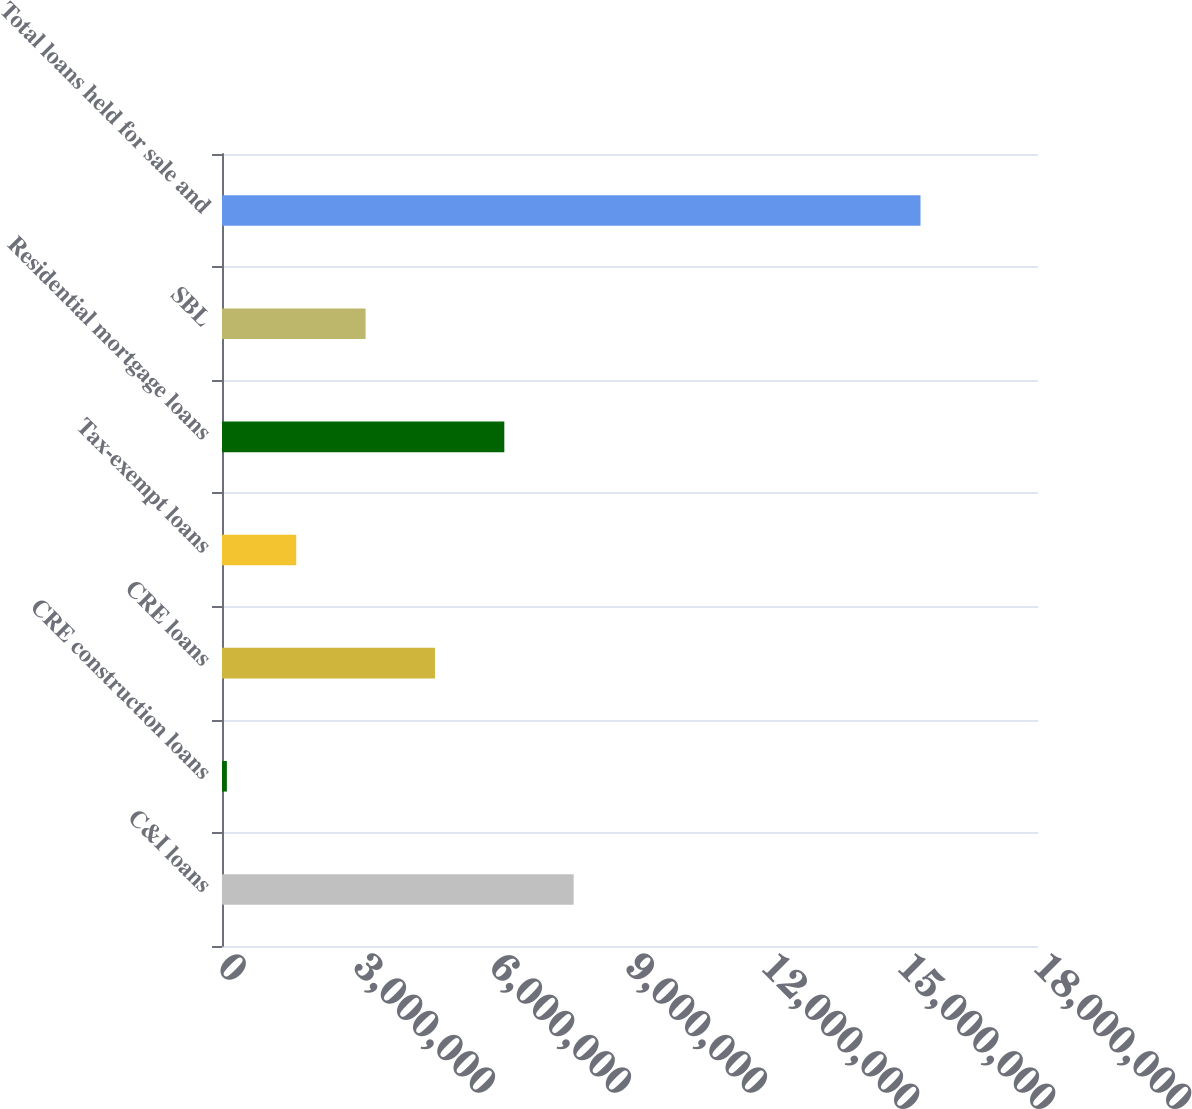Convert chart to OTSL. <chart><loc_0><loc_0><loc_500><loc_500><bar_chart><fcel>C&I loans<fcel>CRE construction loans<fcel>CRE loans<fcel>Tax-exempt loans<fcel>Residential mortgage loans<fcel>SBL<fcel>Total loans held for sale and<nl><fcel>7.75778e+06<fcel>107437<fcel>4.69764e+06<fcel>1.6375e+06<fcel>6.22771e+06<fcel>3.16757e+06<fcel>1.54081e+07<nl></chart> 